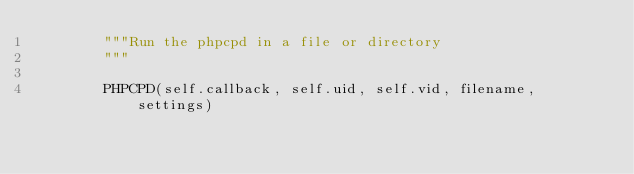Convert code to text. <code><loc_0><loc_0><loc_500><loc_500><_Python_>        """Run the phpcpd in a file or directory
        """

        PHPCPD(self.callback, self.uid, self.vid, filename, settings)
</code> 